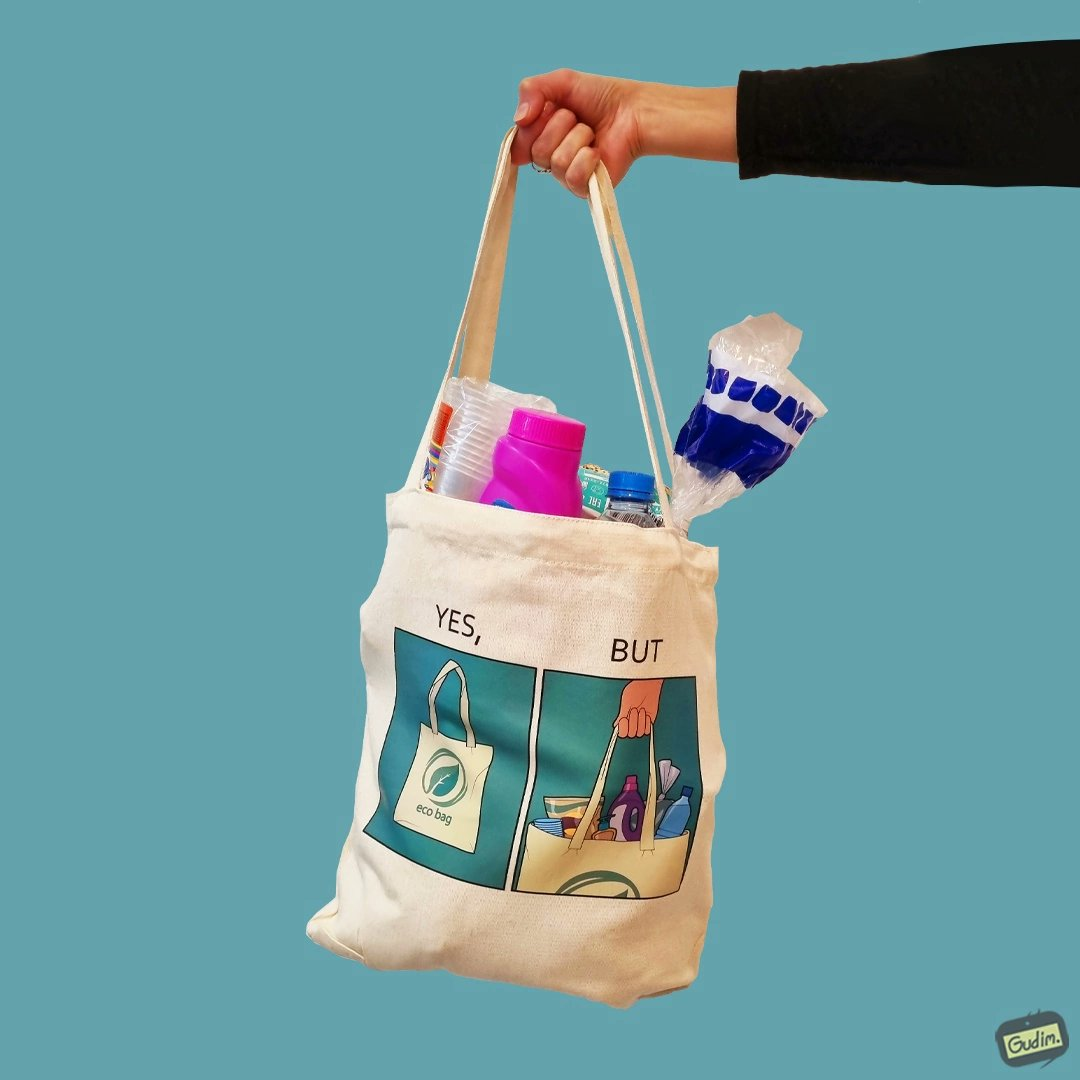What does this image depict? The image is ironical because in the left image it is written eco bag but in the right image we are keeping items of plastic which is not eco-friendly. 